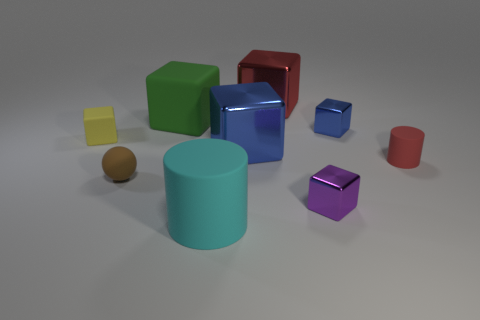Is the color of the big rubber cube the same as the tiny sphere?
Give a very brief answer. No. What material is the thing that is to the left of the cyan matte thing and behind the yellow thing?
Give a very brief answer. Rubber. The purple metal cube has what size?
Your response must be concise. Small. What number of blocks are on the left side of the blue block that is behind the blue object that is in front of the yellow matte thing?
Offer a terse response. 5. There is a metallic object that is on the left side of the big red shiny object that is behind the cyan matte object; what is its shape?
Your response must be concise. Cube. The cyan thing that is the same shape as the small red matte thing is what size?
Make the answer very short. Large. Is there anything else that is the same size as the cyan matte cylinder?
Your answer should be compact. Yes. There is a rubber thing on the right side of the cyan thing; what is its color?
Your answer should be very brief. Red. There is a cylinder on the right side of the big blue object on the left side of the blue object right of the large red metal cube; what is it made of?
Keep it short and to the point. Rubber. There is a cylinder that is on the right side of the big matte thing on the right side of the green block; how big is it?
Provide a short and direct response. Small. 